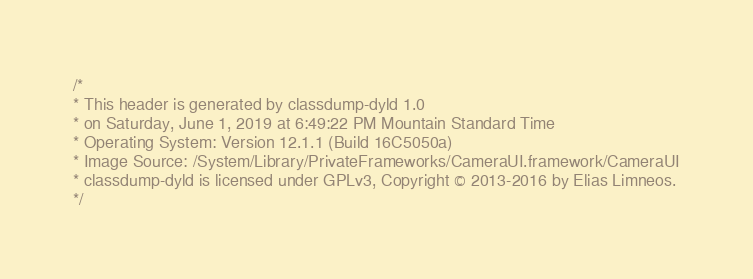<code> <loc_0><loc_0><loc_500><loc_500><_C_>/*
* This header is generated by classdump-dyld 1.0
* on Saturday, June 1, 2019 at 6:49:22 PM Mountain Standard Time
* Operating System: Version 12.1.1 (Build 16C5050a)
* Image Source: /System/Library/PrivateFrameworks/CameraUI.framework/CameraUI
* classdump-dyld is licensed under GPLv3, Copyright © 2013-2016 by Elias Limneos.
*/

</code> 